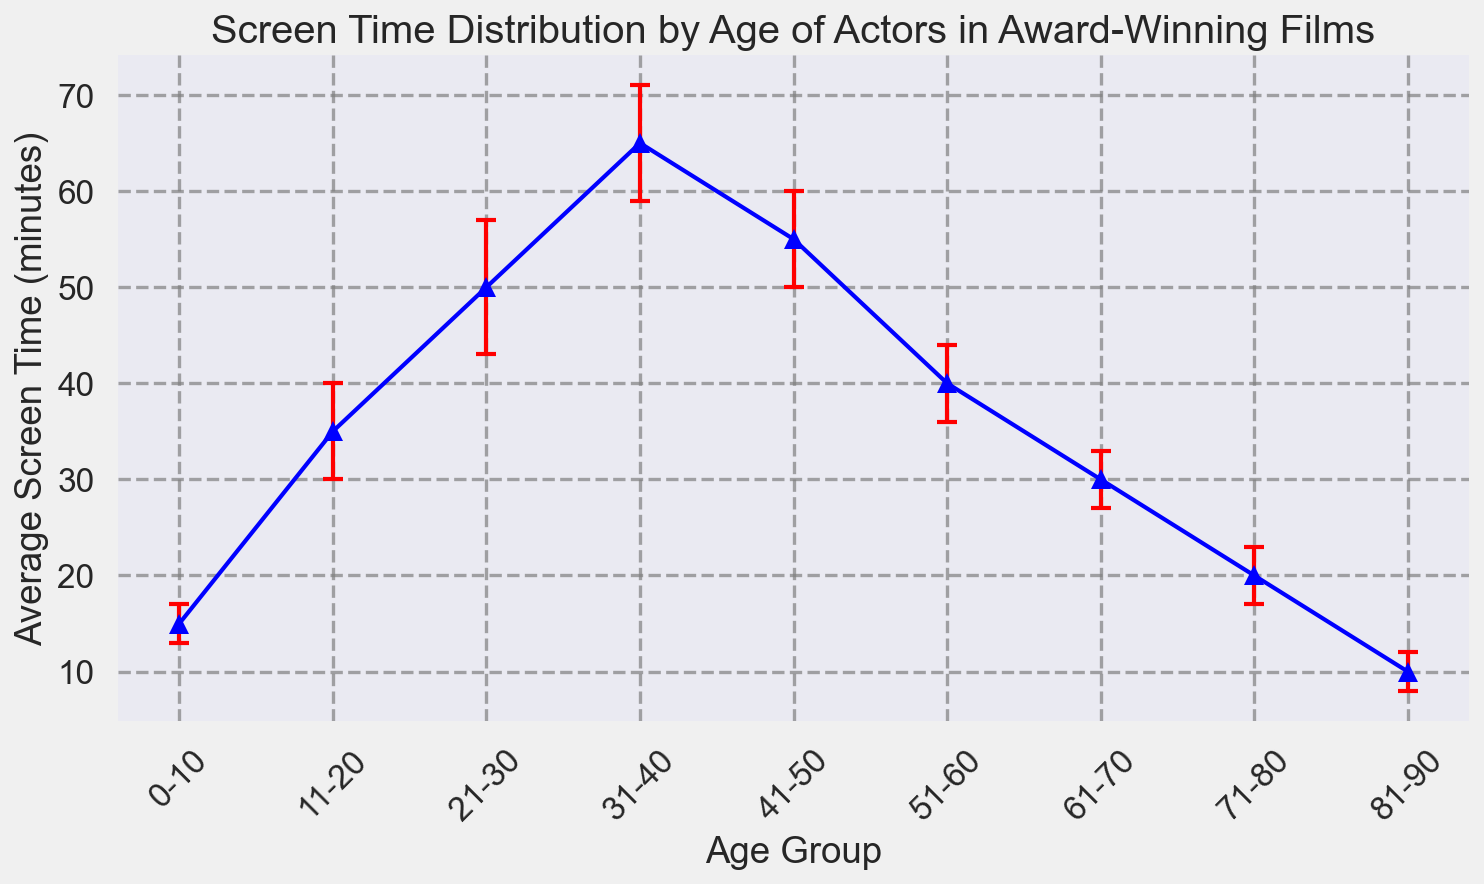Which age group has the highest average screen time? First, identify the average screen time for each age group. The group with the highest average screen time is "31-40" with 65 minutes.
Answer: 31-40 Which age group has the second lowest average screen time? Eye the list of average screen times for each age group. The lowest is the "81-90" group with 10 minutes, and the second lowest is the "0-10" group with 15 minutes.
Answer: 0-10 What is the total average screen time for actors in the 0-10, 51-60, and 81-90 age groups? Add the average screen times for these groups: 15 (0-10) + 40 (51-60) + 10 (81-90). The sum is 65 minutes.
Answer: 65 Which has a larger error margin, the "21-30" or the "41-50" age group? Compare the error margins of these age groups. The "21-30" age group has a 7-minute error margin, while the "41-50" age group has a 5-minute error margin, so "21-30" is larger.
Answer: 21-30 Between which two consecutive age groups is the difference in average screen time the highest? Calculate the differences between consecutive groups: 
  - 11-20 and 0-10: 35 - 15 = 20 minutes
  - 21-30 and 11-20: 50 - 35 = 15 minutes
  - 31-40 and 21-30: 65 - 50 = 15 minutes
  - 41-50 and 31-40: 55 - 65 = 10 minutes (absolute value)
  - 51-60 and 41-50: 40 - 55 = 15 minutes (absolute value)
  - 61-70 and 51-60: 30 - 40 = 10 minutes (absolute value)
  - 71-80 and 61-70: 20 - 30 = 10 minutes (absolute value)
  - 81-90 and 71-80: 10 - 20 = 10 minutes (absolute value)
  The greatest difference is between "11-20" and "0-10" with 20 minutes.
Answer: 11-20 and 0-10 On average, does the error margin increase or decrease with age? Visually observe the trend of error margins across age groups. The error margin is not consistent as it increases for the middle age groups (peaks at "21-30" with 7 minutes) and generally decreases for older age groups.
Answer: Decrease What is the average screen time for actors aged above 50? Average the screen times for "51-60", "61-70", "71-80", and "81-90":
  - (40 + 30 + 20 + 10) / 4 = 25 minutes.
Answer: 25 Which age group has the highest variability in screen time? Identify the age group with the largest error margin as it represents the variability. The "21-30" age group has the highest error margin with 7 minutes.
Answer: 21-30 